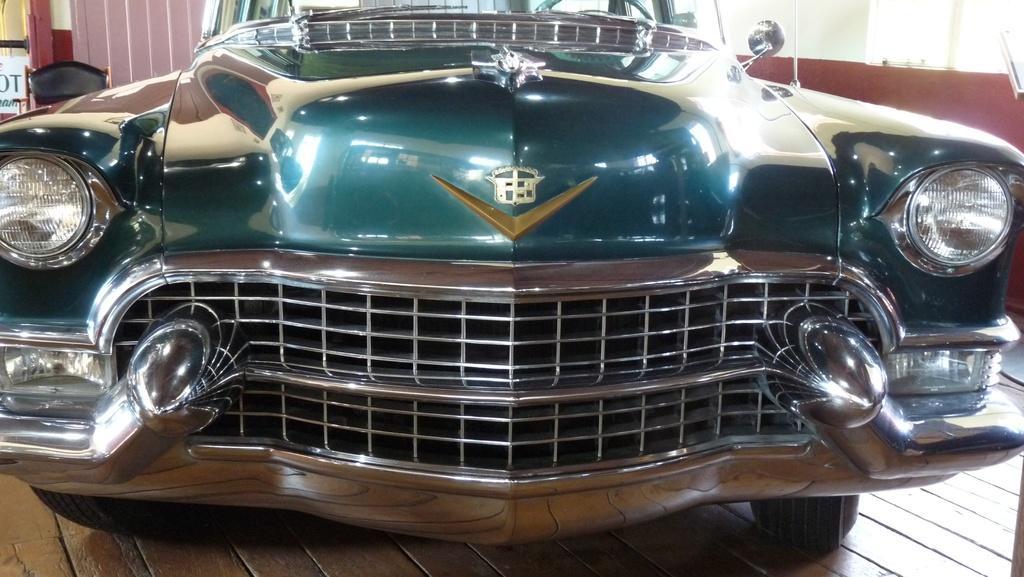In one or two sentences, can you explain what this image depicts? In this image we can see a close view of a car. 